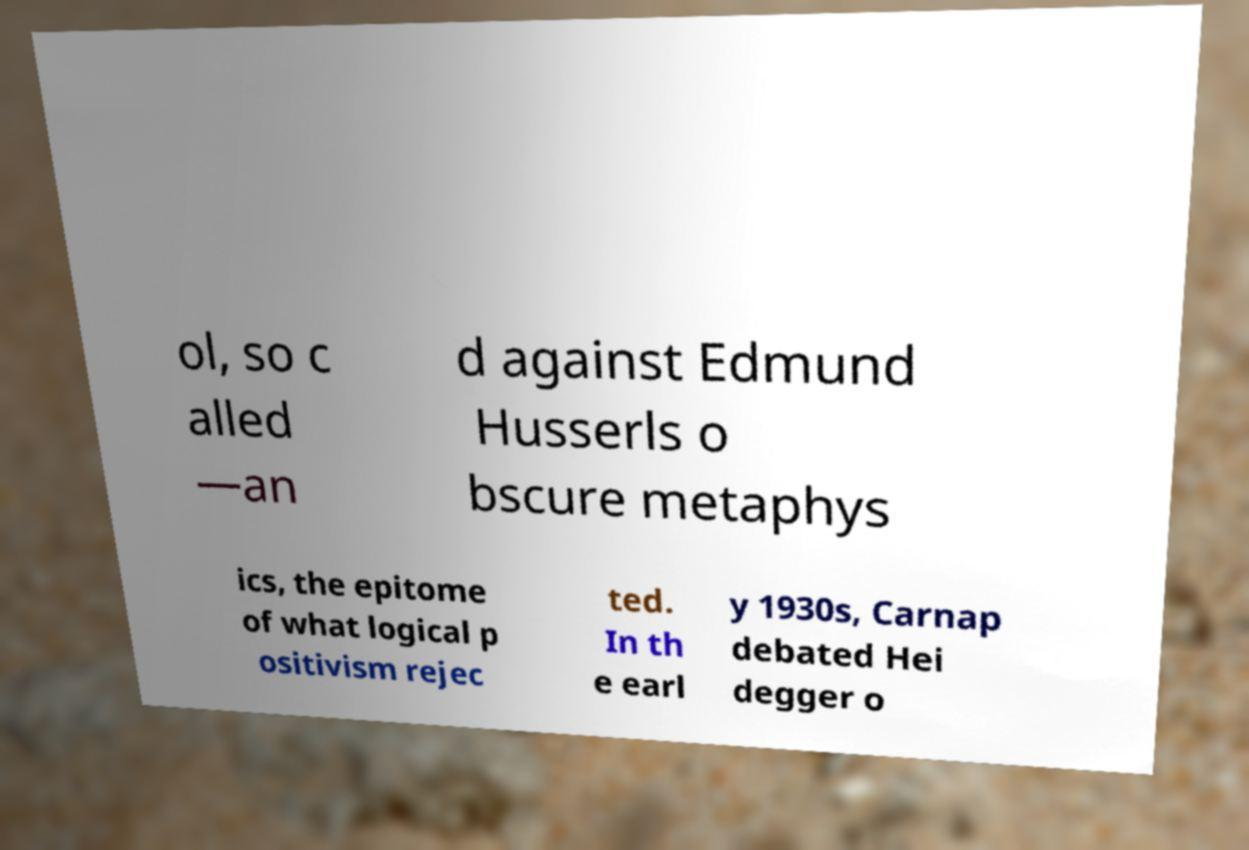There's text embedded in this image that I need extracted. Can you transcribe it verbatim? ol, so c alled —an d against Edmund Husserls o bscure metaphys ics, the epitome of what logical p ositivism rejec ted. In th e earl y 1930s, Carnap debated Hei degger o 